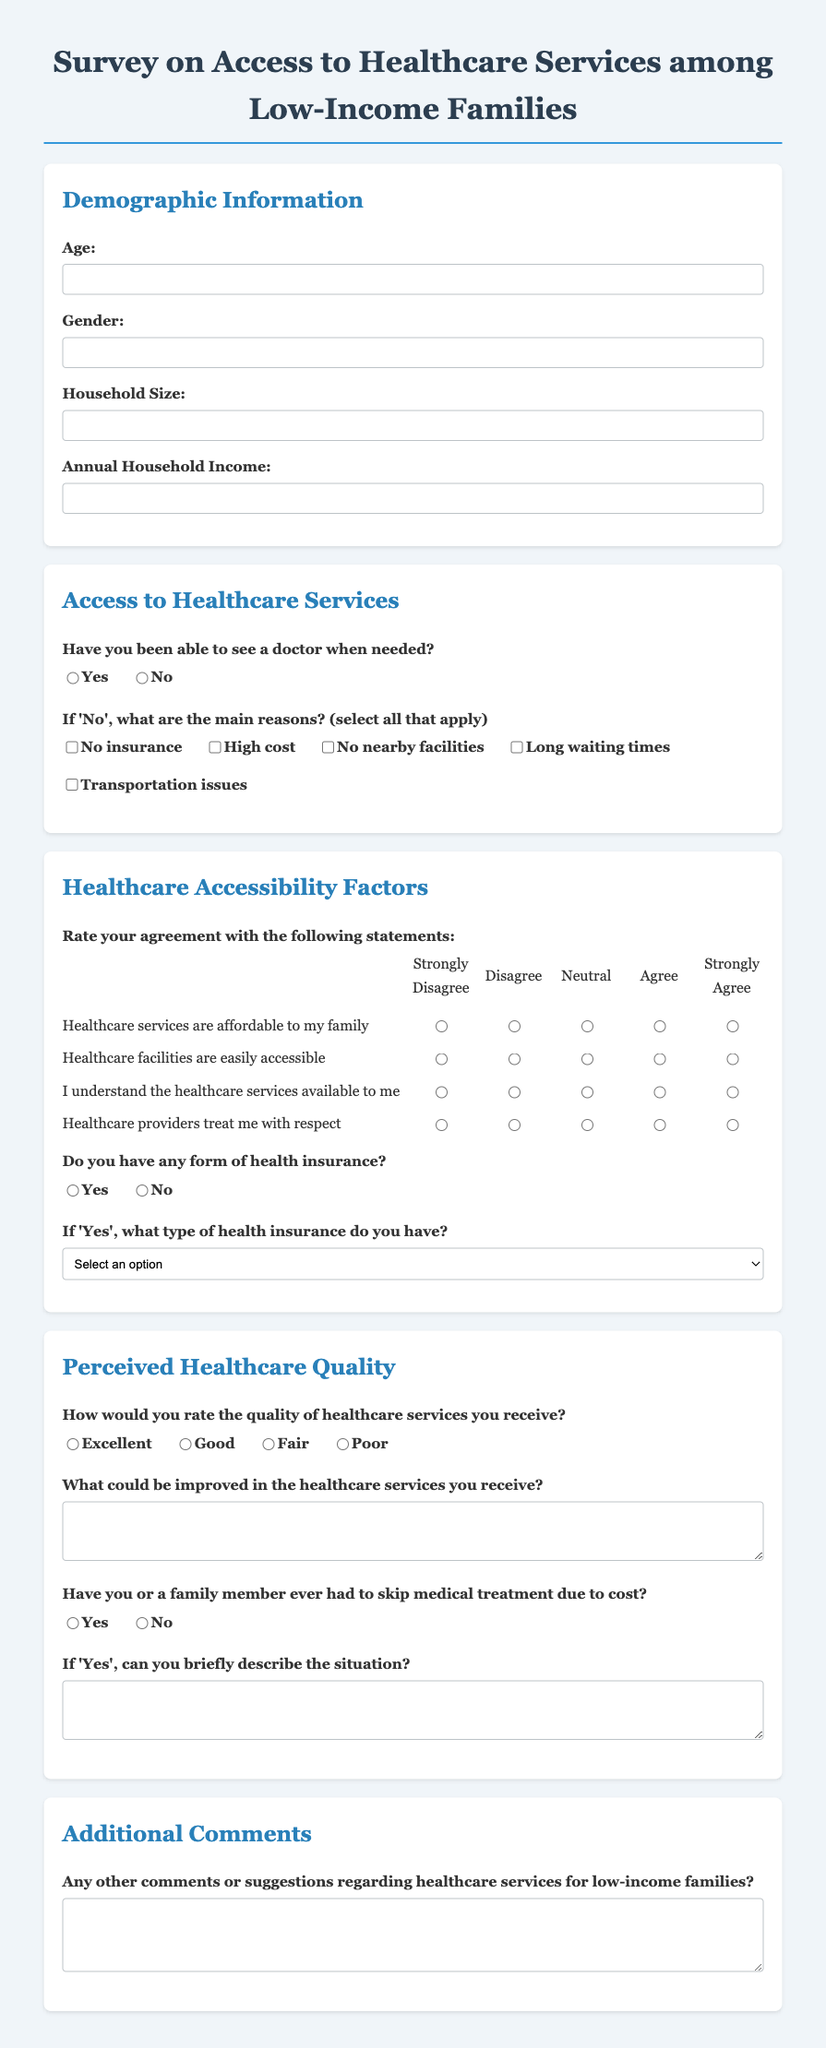What is the title of the survey? The title of the survey is found in the document's heading, which describes the focus of the survey on healthcare access for a specific demographic.
Answer: Survey on Access to Healthcare Services among Low-Income Families How many sections are in the survey? The document contains multiple sections that break down the survey into manageable parts, including demographic information and access to healthcare services.
Answer: Four What type of input is requested for annual household income? The survey asks for a specific type of numeric input, indicating the financial capacity of the respondents.
Answer: Number Which statement requires agreement regarding healthcare affordability? Respondents are prompted to rate their level of agreement with a statement that reflects the economic accessibility of healthcare services.
Answer: Healthcare services are affordable to my family What is the scale for rating healthcare service accessibility? The document presents a structured format for respondents to express their opinions, employing a specific numeric rating scale that aligns with common survey practices.
Answer: 1 to 5 What should respondents do if they answer 'No' to seeing a doctor when needed? The survey gives clear instructions on what respondents must elaborate upon if they reveal barriers to accessing healthcare.
Answer: Select all that apply What options are available for health insurance types? A list is provided to differentiate the types of health insurance that survey participants may possess, enabling more nuanced insights into their coverage status.
Answer: Private Insurance, Medicaid, Medicare, State-Funded Programs, Other How are healthcare services rated in this survey? The document includes a specific question that enables respondents to assess their experiences with healthcare services, which helps gauge perceived quality.
Answer: Excellent, Good, Fair, Poor What is solicited in the additional comments section? The final section allows participants to convey their thoughts and suggestions regarding the overall topic of the survey, encouraging open-ended feedback.
Answer: Comments or suggestions regarding healthcare services 